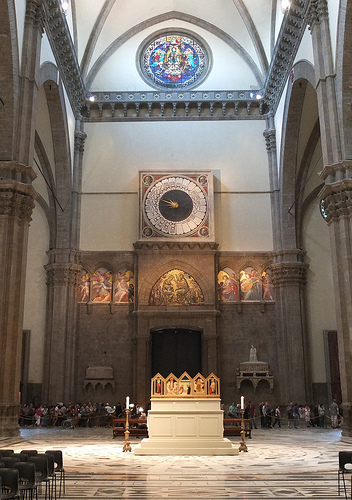What is the time shown on the clock? The clock in the image appears to show a time of around 8:15. Is the clock a typical design or does it have any unique features? The clock has a unique and historical design, typical of structures from the Gothic era. It's large, positioned high above the main area, and surrounded by ornate decorations and artwork, which add to its grandeur and historical significance. 